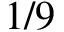Convert formula to latex. <formula><loc_0><loc_0><loc_500><loc_500>1 / 9</formula> 